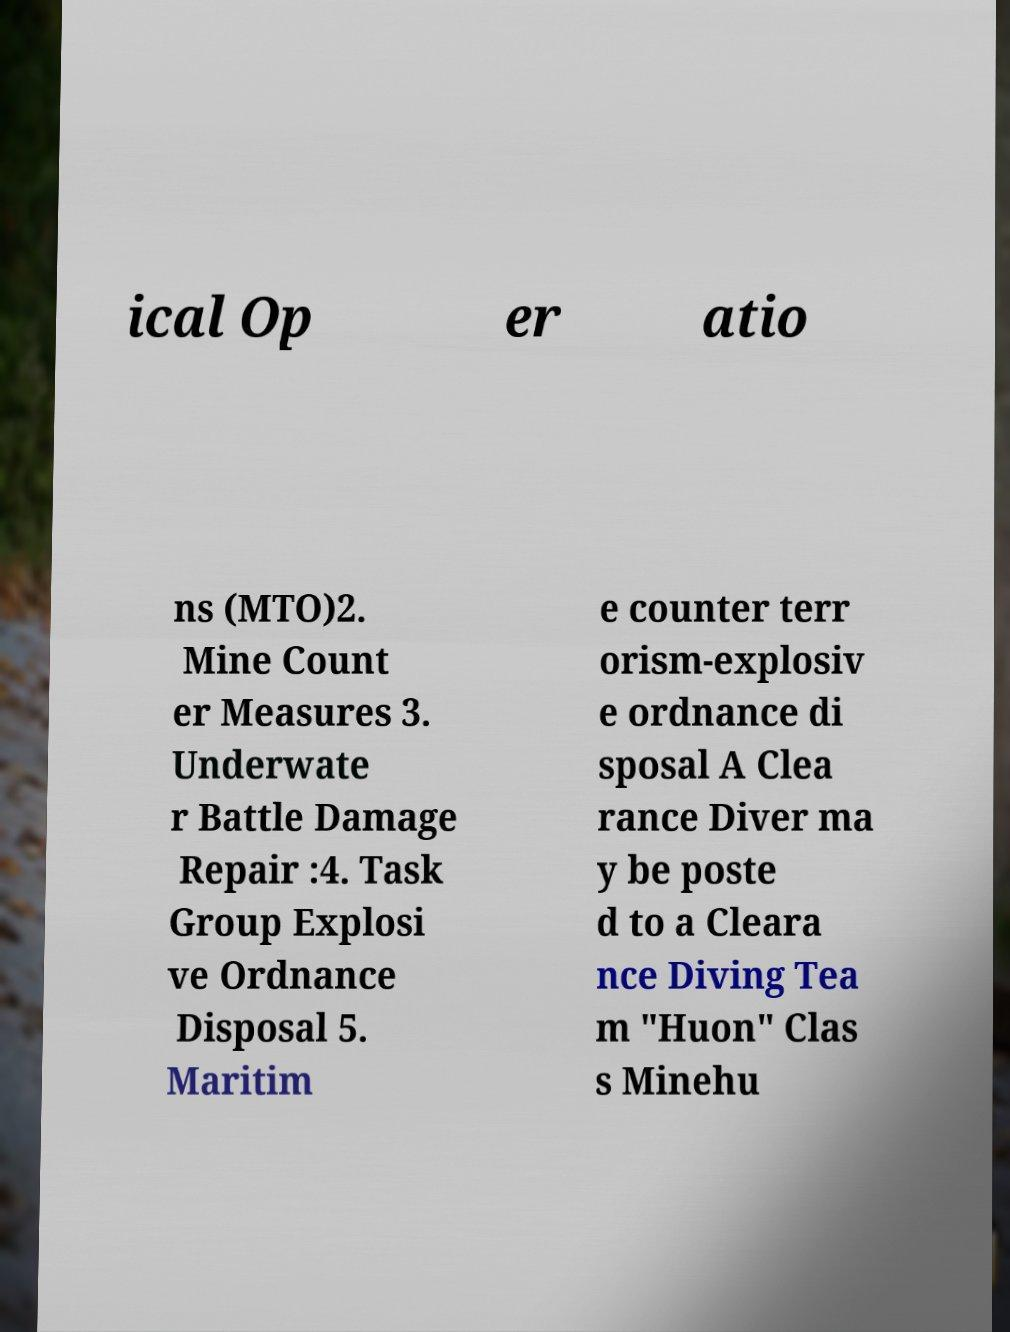Can you read and provide the text displayed in the image?This photo seems to have some interesting text. Can you extract and type it out for me? ical Op er atio ns (MTO)2. Mine Count er Measures 3. Underwate r Battle Damage Repair :4. Task Group Explosi ve Ordnance Disposal 5. Maritim e counter terr orism-explosiv e ordnance di sposal A Clea rance Diver ma y be poste d to a Cleara nce Diving Tea m "Huon" Clas s Minehu 